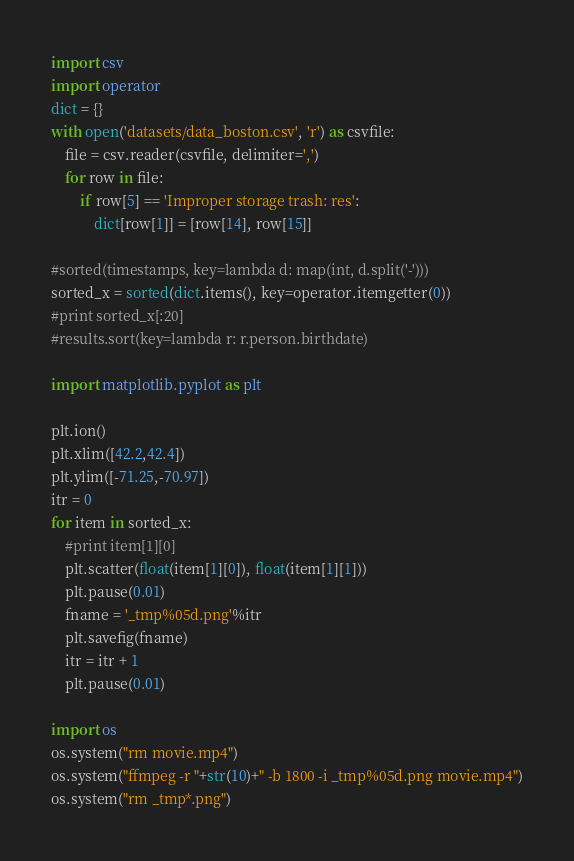<code> <loc_0><loc_0><loc_500><loc_500><_Python_>import csv 
import operator
dict = {}
with open('datasets/data_boston.csv', 'r') as csvfile:
	file = csv.reader(csvfile, delimiter=',')
	for row in file:
		if row[5] == 'Improper storage trash: res':
			dict[row[1]] = [row[14], row[15]]

#sorted(timestamps, key=lambda d: map(int, d.split('-')))
sorted_x = sorted(dict.items(), key=operator.itemgetter(0))
#print sorted_x[:20]
#results.sort(key=lambda r: r.person.birthdate)

import matplotlib.pyplot as plt

plt.ion()
plt.xlim([42.2,42.4])
plt.ylim([-71.25,-70.97])
itr = 0
for item in sorted_x:
	#print item[1][0]
	plt.scatter(float(item[1][0]), float(item[1][1]))
	plt.pause(0.01)
	fname = '_tmp%05d.png'%itr
	plt.savefig(fname)
	itr = itr + 1 
	plt.pause(0.01)

import os
os.system("rm movie.mp4")
os.system("ffmpeg -r "+str(10)+" -b 1800 -i _tmp%05d.png movie.mp4")
os.system("rm _tmp*.png")
</code> 